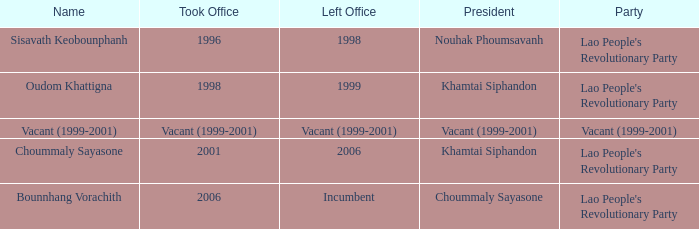What is Left Office, when Took Office is 1998? 1999.0. 